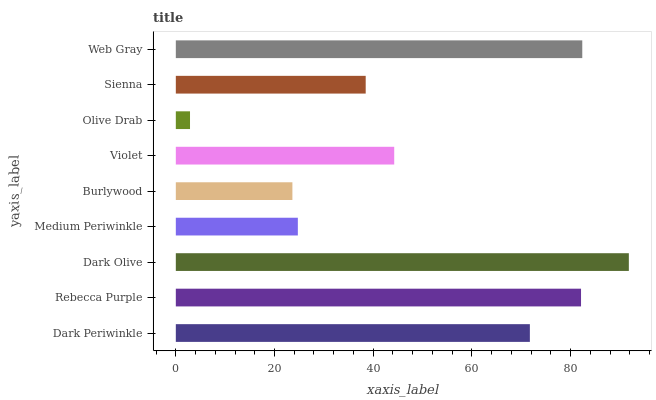Is Olive Drab the minimum?
Answer yes or no. Yes. Is Dark Olive the maximum?
Answer yes or no. Yes. Is Rebecca Purple the minimum?
Answer yes or no. No. Is Rebecca Purple the maximum?
Answer yes or no. No. Is Rebecca Purple greater than Dark Periwinkle?
Answer yes or no. Yes. Is Dark Periwinkle less than Rebecca Purple?
Answer yes or no. Yes. Is Dark Periwinkle greater than Rebecca Purple?
Answer yes or no. No. Is Rebecca Purple less than Dark Periwinkle?
Answer yes or no. No. Is Violet the high median?
Answer yes or no. Yes. Is Violet the low median?
Answer yes or no. Yes. Is Sienna the high median?
Answer yes or no. No. Is Rebecca Purple the low median?
Answer yes or no. No. 